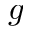Convert formula to latex. <formula><loc_0><loc_0><loc_500><loc_500>g</formula> 